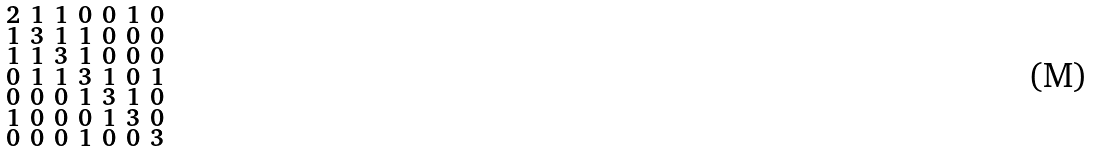<formula> <loc_0><loc_0><loc_500><loc_500>\begin{smallmatrix} 2 & 1 & 1 & 0 & 0 & 1 & 0 \\ 1 & 3 & 1 & 1 & 0 & 0 & 0 \\ 1 & 1 & 3 & 1 & 0 & 0 & 0 \\ 0 & 1 & 1 & 3 & 1 & 0 & 1 \\ 0 & 0 & 0 & 1 & 3 & 1 & 0 \\ 1 & 0 & 0 & 0 & 1 & 3 & 0 \\ 0 & 0 & 0 & 1 & 0 & 0 & 3 \end{smallmatrix}</formula> 